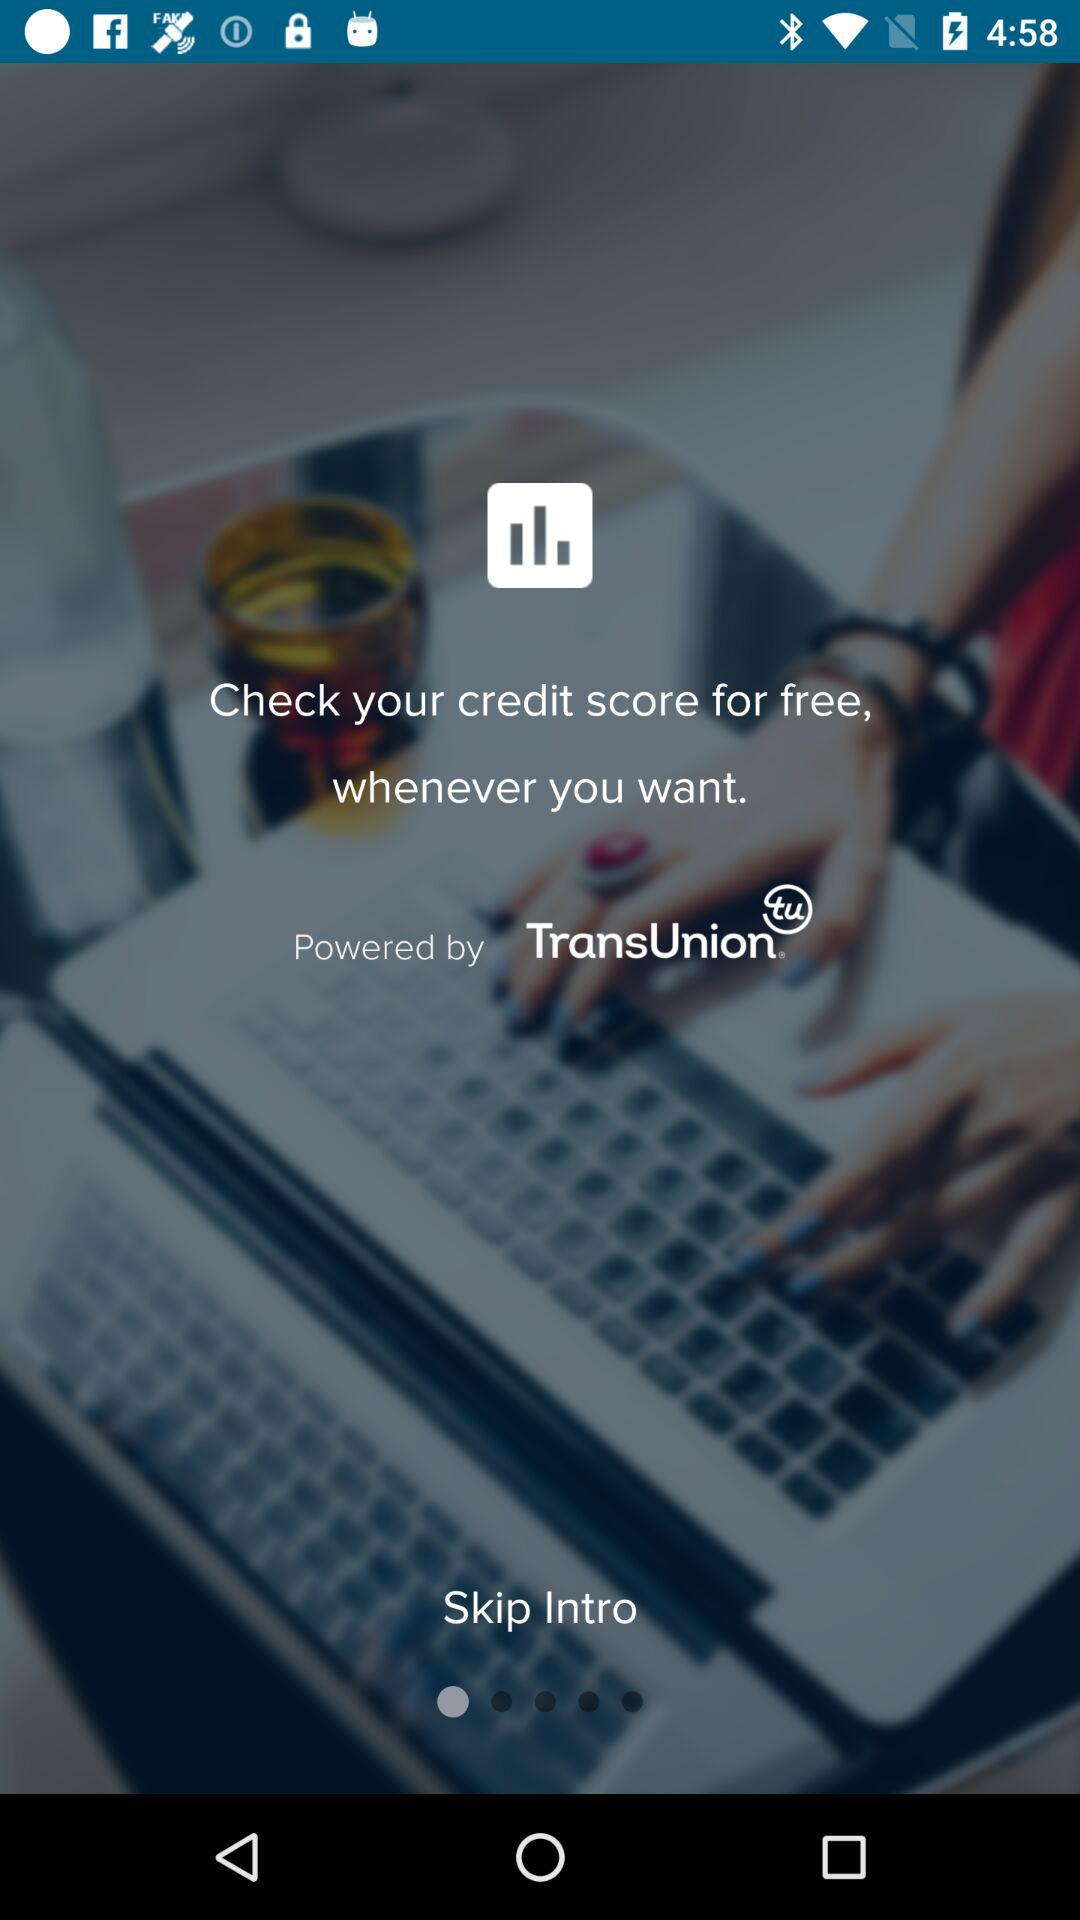Whom this application is powered by? It is powered by "TransUnion". 